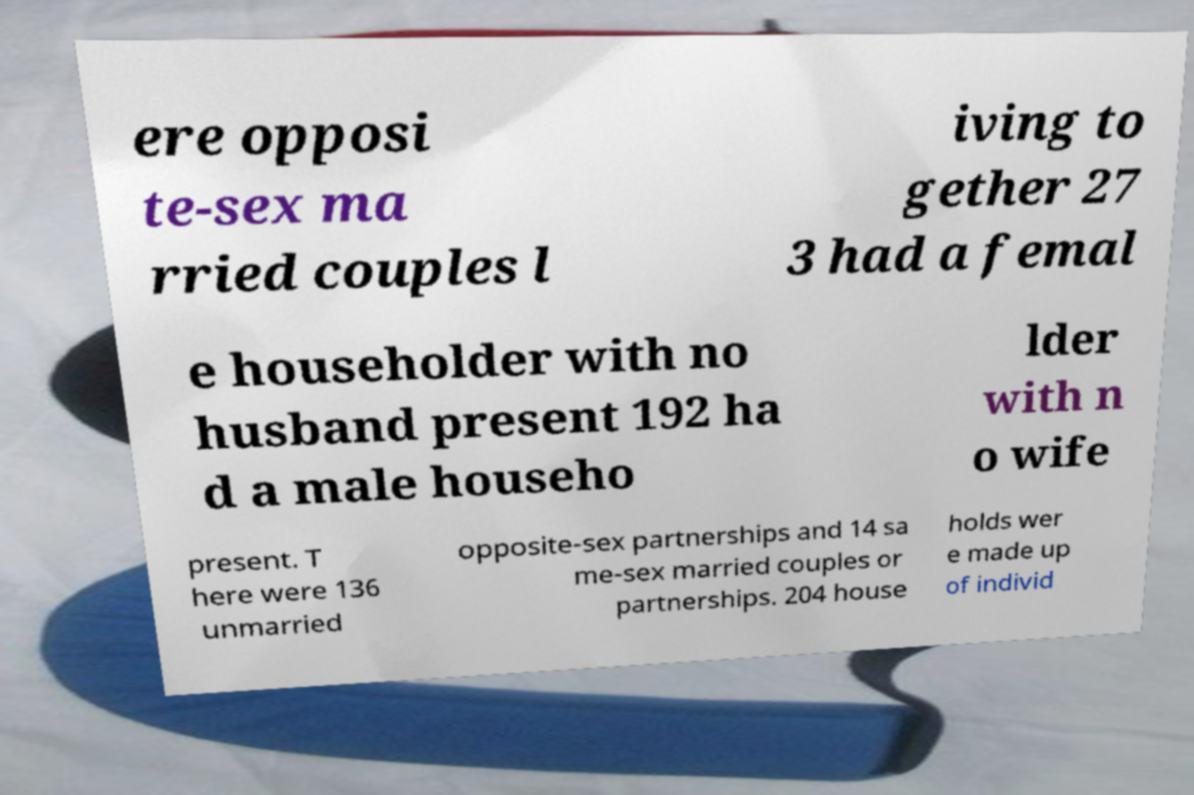Please identify and transcribe the text found in this image. ere opposi te-sex ma rried couples l iving to gether 27 3 had a femal e householder with no husband present 192 ha d a male househo lder with n o wife present. T here were 136 unmarried opposite-sex partnerships and 14 sa me-sex married couples or partnerships. 204 house holds wer e made up of individ 